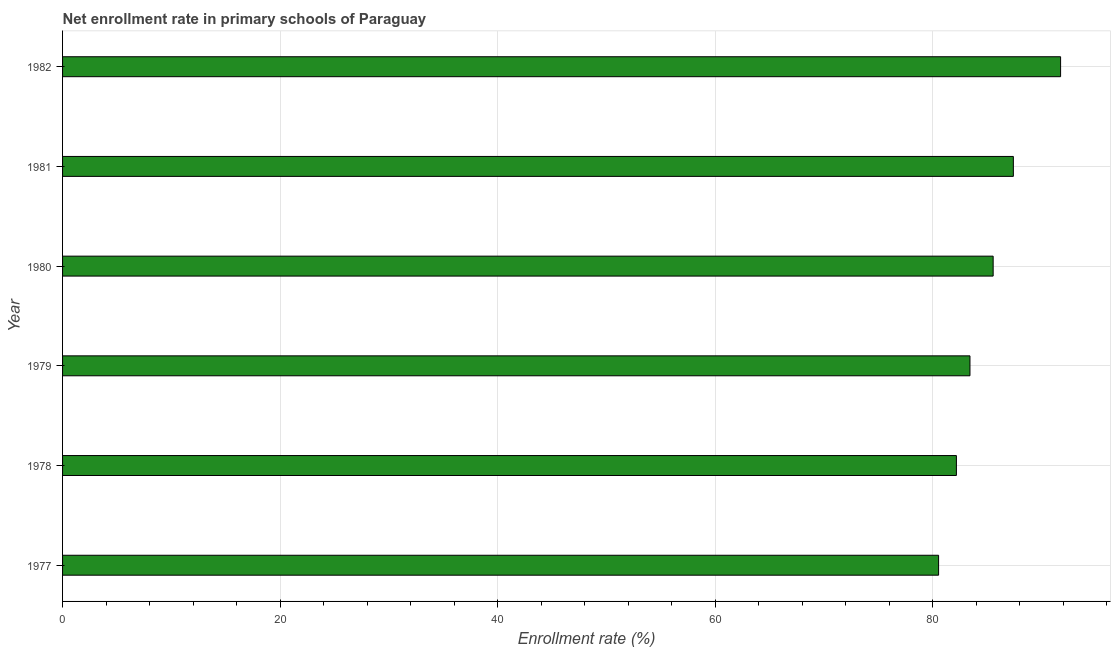Does the graph contain any zero values?
Make the answer very short. No. What is the title of the graph?
Your answer should be compact. Net enrollment rate in primary schools of Paraguay. What is the label or title of the X-axis?
Keep it short and to the point. Enrollment rate (%). What is the label or title of the Y-axis?
Provide a short and direct response. Year. What is the net enrollment rate in primary schools in 1978?
Make the answer very short. 82.18. Across all years, what is the maximum net enrollment rate in primary schools?
Offer a very short reply. 91.76. Across all years, what is the minimum net enrollment rate in primary schools?
Your answer should be compact. 80.54. What is the sum of the net enrollment rate in primary schools?
Offer a very short reply. 510.87. What is the difference between the net enrollment rate in primary schools in 1979 and 1982?
Provide a succinct answer. -8.33. What is the average net enrollment rate in primary schools per year?
Your answer should be very brief. 85.14. What is the median net enrollment rate in primary schools?
Provide a short and direct response. 84.49. In how many years, is the net enrollment rate in primary schools greater than 76 %?
Give a very brief answer. 6. What is the ratio of the net enrollment rate in primary schools in 1977 to that in 1981?
Your answer should be very brief. 0.92. Is the net enrollment rate in primary schools in 1977 less than that in 1979?
Offer a terse response. Yes. What is the difference between the highest and the second highest net enrollment rate in primary schools?
Your answer should be compact. 4.34. What is the difference between the highest and the lowest net enrollment rate in primary schools?
Ensure brevity in your answer.  11.22. Are all the bars in the graph horizontal?
Offer a terse response. Yes. What is the difference between two consecutive major ticks on the X-axis?
Make the answer very short. 20. Are the values on the major ticks of X-axis written in scientific E-notation?
Keep it short and to the point. No. What is the Enrollment rate (%) of 1977?
Give a very brief answer. 80.54. What is the Enrollment rate (%) of 1978?
Give a very brief answer. 82.18. What is the Enrollment rate (%) in 1979?
Your response must be concise. 83.42. What is the Enrollment rate (%) of 1980?
Your answer should be compact. 85.56. What is the Enrollment rate (%) in 1981?
Offer a terse response. 87.41. What is the Enrollment rate (%) in 1982?
Provide a short and direct response. 91.76. What is the difference between the Enrollment rate (%) in 1977 and 1978?
Your answer should be compact. -1.64. What is the difference between the Enrollment rate (%) in 1977 and 1979?
Your response must be concise. -2.88. What is the difference between the Enrollment rate (%) in 1977 and 1980?
Offer a terse response. -5.02. What is the difference between the Enrollment rate (%) in 1977 and 1981?
Offer a very short reply. -6.87. What is the difference between the Enrollment rate (%) in 1977 and 1982?
Give a very brief answer. -11.22. What is the difference between the Enrollment rate (%) in 1978 and 1979?
Your answer should be very brief. -1.25. What is the difference between the Enrollment rate (%) in 1978 and 1980?
Ensure brevity in your answer.  -3.38. What is the difference between the Enrollment rate (%) in 1978 and 1981?
Offer a terse response. -5.24. What is the difference between the Enrollment rate (%) in 1978 and 1982?
Your answer should be compact. -9.58. What is the difference between the Enrollment rate (%) in 1979 and 1980?
Your answer should be very brief. -2.13. What is the difference between the Enrollment rate (%) in 1979 and 1981?
Your answer should be compact. -3.99. What is the difference between the Enrollment rate (%) in 1979 and 1982?
Offer a terse response. -8.33. What is the difference between the Enrollment rate (%) in 1980 and 1981?
Make the answer very short. -1.86. What is the difference between the Enrollment rate (%) in 1980 and 1982?
Give a very brief answer. -6.2. What is the difference between the Enrollment rate (%) in 1981 and 1982?
Your response must be concise. -4.34. What is the ratio of the Enrollment rate (%) in 1977 to that in 1980?
Offer a terse response. 0.94. What is the ratio of the Enrollment rate (%) in 1977 to that in 1981?
Keep it short and to the point. 0.92. What is the ratio of the Enrollment rate (%) in 1977 to that in 1982?
Provide a short and direct response. 0.88. What is the ratio of the Enrollment rate (%) in 1978 to that in 1981?
Provide a succinct answer. 0.94. What is the ratio of the Enrollment rate (%) in 1978 to that in 1982?
Your answer should be compact. 0.9. What is the ratio of the Enrollment rate (%) in 1979 to that in 1980?
Offer a very short reply. 0.97. What is the ratio of the Enrollment rate (%) in 1979 to that in 1981?
Offer a very short reply. 0.95. What is the ratio of the Enrollment rate (%) in 1979 to that in 1982?
Provide a short and direct response. 0.91. What is the ratio of the Enrollment rate (%) in 1980 to that in 1981?
Keep it short and to the point. 0.98. What is the ratio of the Enrollment rate (%) in 1980 to that in 1982?
Your answer should be very brief. 0.93. What is the ratio of the Enrollment rate (%) in 1981 to that in 1982?
Offer a very short reply. 0.95. 